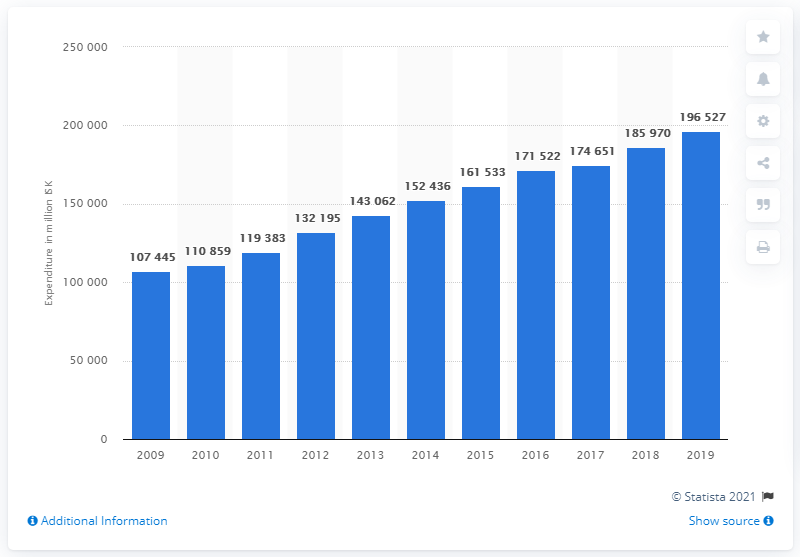Give some essential details in this illustration. In 2019, Iceland spent 196,527 on food and non-alcoholic beverages. In 2009, Iceland saw an increase in the consumption of food and non-alcoholic beverages. 